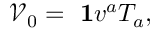<formula> <loc_0><loc_0><loc_500><loc_500>{ \ \mathcal { V } } _ { 0 } = { 1 } v ^ { a } T _ { a } ,</formula> 